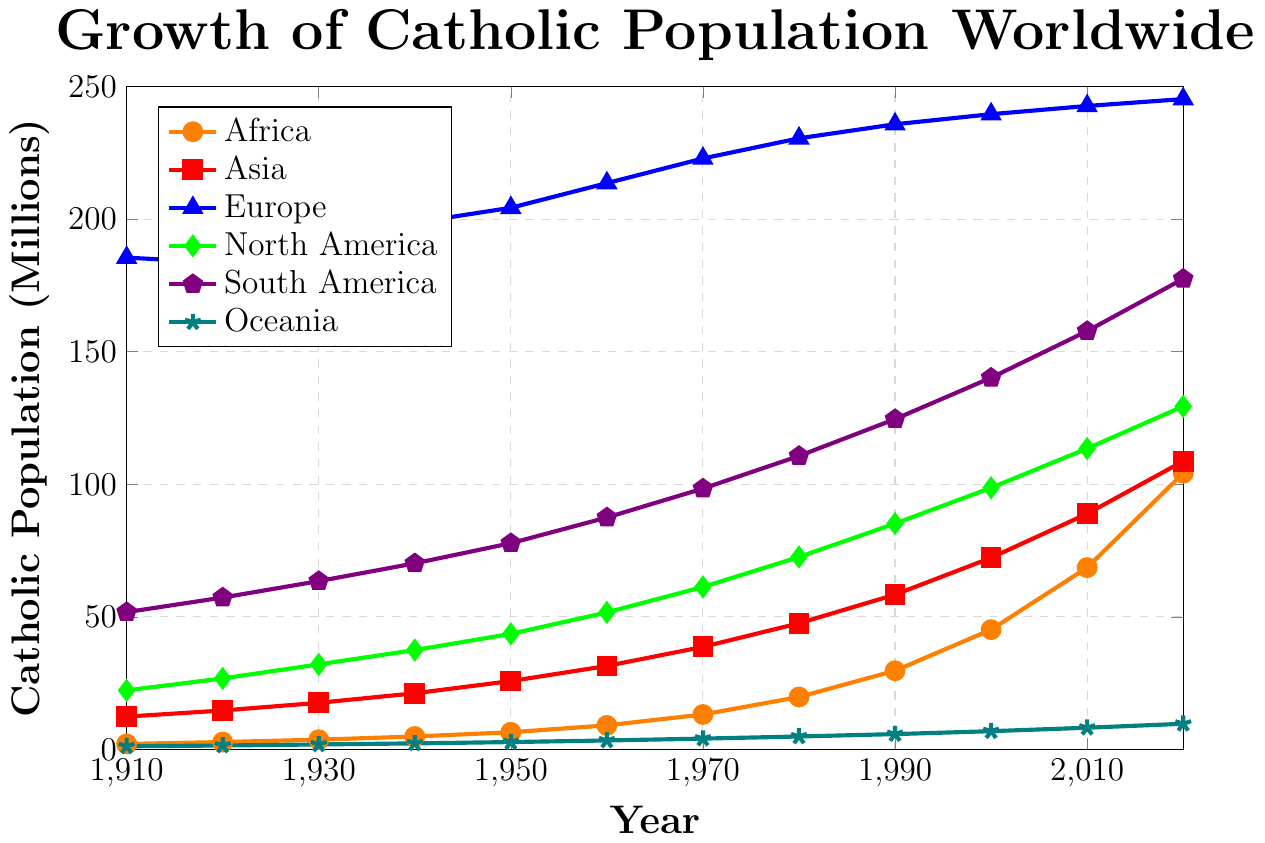Which continent had the highest Catholic population in 1910? From the figure, we can see that Europe had the highest Catholic population in 1910, indicated by the peak of the blue line at the year 1910.
Answer: Europe Between 1910 and 2020, which continent experienced the most significant increase in Catholic population? By comparing the starting and ending points for each continent, we see that Africa (orange line) shows the most dramatic increase from 2.1 million to 104.2 million.
Answer: Africa What was the average Catholic population in North America between 1910 and 2020? Sum the North American values for each decade: 22.3 + 26.8 + 32.1 + 37.5 + 43.6 + 51.7 + 61.3 + 72.6 + 85.2 + 98.7 + 113.5 + 129.4 = 775.7 million. There are 12 data points, so the average is 775.7 / 12 ≈ 64.6.
Answer: 64.6 million Compare the Catholic population growth trends of Asia and Europe from 1910 to 2020. Asia (red line) starts at 12.4 million in 1910 and reaches 108.7 million in 2020, showing steady growth. Europe (blue line) starts at 185.5 million and ends at 245.3 million. Europe's growth is slower, especially after 1950.
Answer: Asia shows faster growth In which year did South America's Catholic population first surpass 100 million? By examining the purple line representing South America, it crosses the 100 million mark around 1970.
Answer: 1970 What is the combined Catholic population of Africa and Asia in 2020? The figure shows Africa at 104.2 million and Asia at 108.7 million in 2020. Their combined population is 104.2 + 108.7 = 212.9 million.
Answer: 212.9 million Which continent shows a nearly linear increase in Catholic population over the century? Observing the lines, Oceania (teal line) shows an almost linear increase from 1.2 million in 1910 to 9.7 million in 2020 without significant fluctuations.
Answer: Oceania Which continent had the least change in Catholic population between 1910 and 2020? Europe (blue line) had the smallest change, starting from 185.5 million in 1910 to 245.3 million in 2020, which is the least relative change compared to other continents.
Answer: Europe 